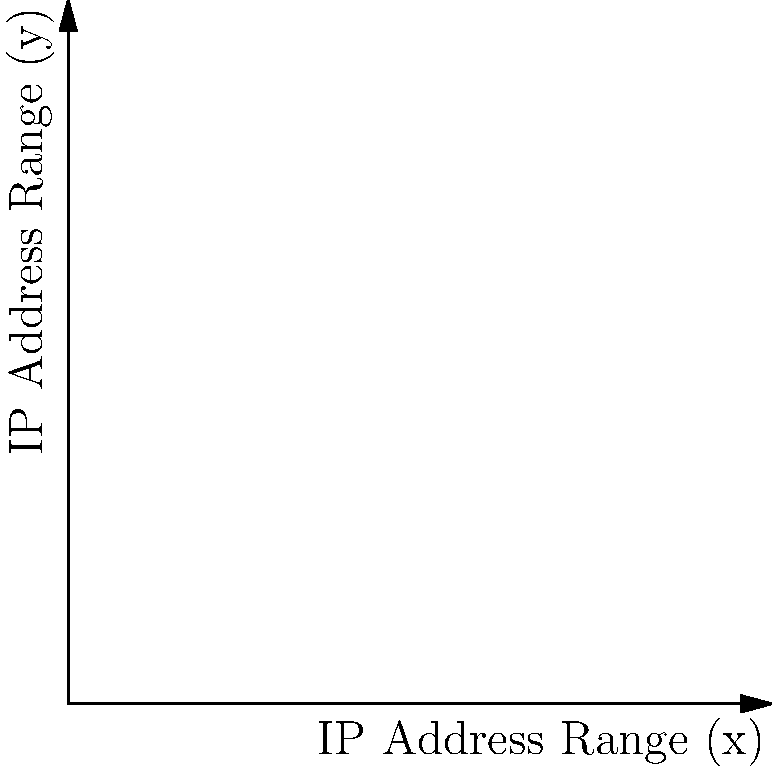In the given IP address clustering visualization, which cluster is most likely to represent potential spam sources based on its density and position? To determine which cluster is most likely to represent potential spam sources, we need to analyze the characteristics of each cluster:

1. Cluster A (Red):
   - Located in the upper-left corner of the graph
   - High density with 4 closely packed points
   - Represents a narrow range of IP addresses

2. Cluster B (Blue):
   - Located in the lower-right corner of the graph
   - Moderate density with 4 points spread slightly wider
   - Represents a slightly broader range of IP addresses

3. Cluster C (Green):
   - Located in the center of the graph
   - Lowest density with 4 points spread wider
   - Represents the broadest range of IP addresses

Spam sources often use a narrow range of IP addresses to send large volumes of messages. This behavior is typically represented by dense clusters in IP address visualizations.

Based on these observations:
- Cluster A shows the highest density and narrowest IP address range, making it the most suspicious for spam activity.
- Cluster B is moderately dense but covers a wider range, making it less likely to be a spam source.
- Cluster C is the least dense and most spread out, indicating normal, diverse traffic patterns.

Therefore, Cluster A is most likely to represent potential spam sources due to its high density and narrow IP address range.
Answer: Cluster A 